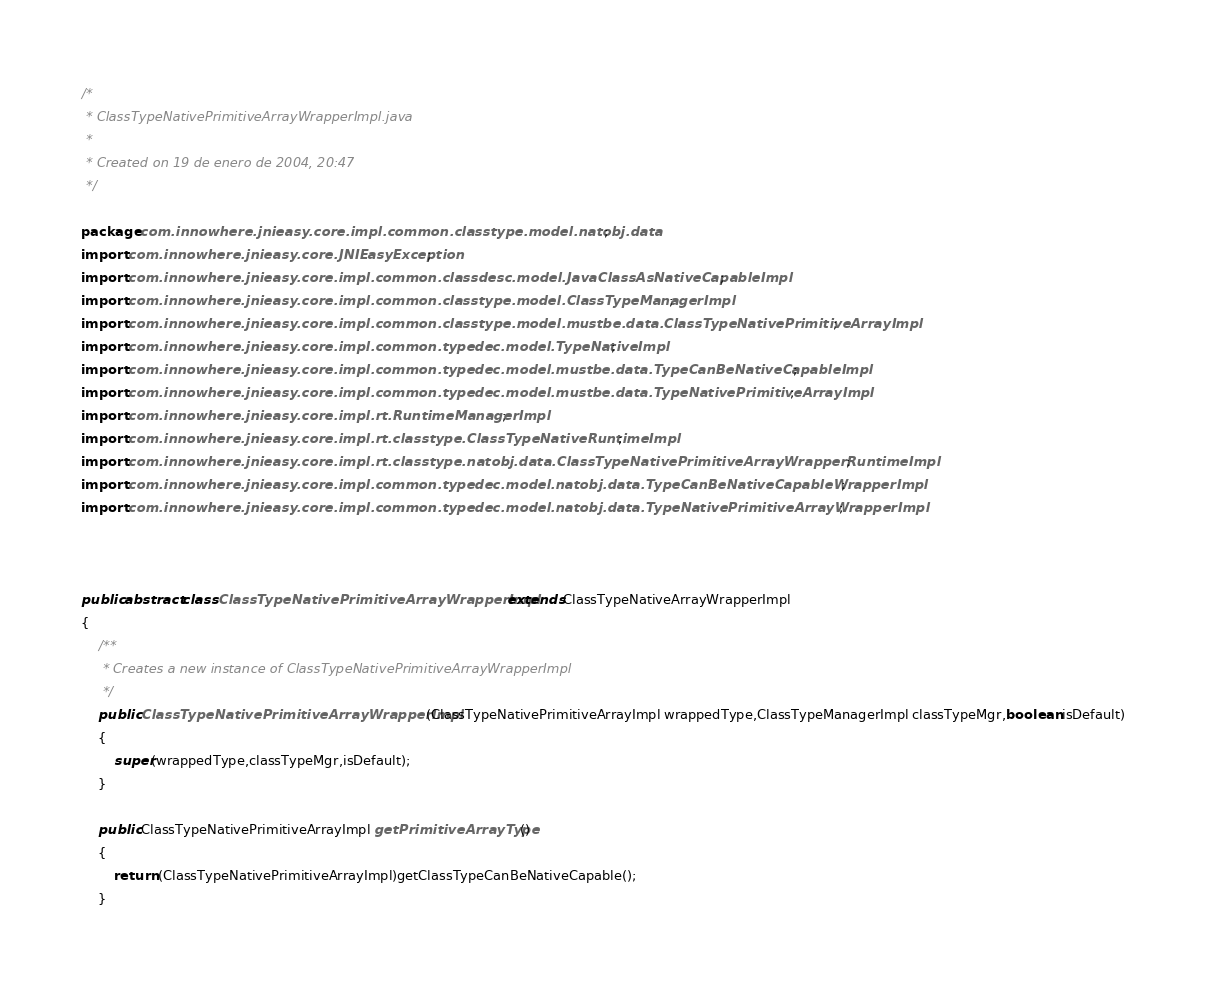Convert code to text. <code><loc_0><loc_0><loc_500><loc_500><_Java_>/*
 * ClassTypeNativePrimitiveArrayWrapperImpl.java
 *
 * Created on 19 de enero de 2004, 20:47
 */

package com.innowhere.jnieasy.core.impl.common.classtype.model.natobj.data;
import com.innowhere.jnieasy.core.JNIEasyException;
import com.innowhere.jnieasy.core.impl.common.classdesc.model.JavaClassAsNativeCapableImpl;
import com.innowhere.jnieasy.core.impl.common.classtype.model.ClassTypeManagerImpl;
import com.innowhere.jnieasy.core.impl.common.classtype.model.mustbe.data.ClassTypeNativePrimitiveArrayImpl;
import com.innowhere.jnieasy.core.impl.common.typedec.model.TypeNativeImpl;
import com.innowhere.jnieasy.core.impl.common.typedec.model.mustbe.data.TypeCanBeNativeCapableImpl;
import com.innowhere.jnieasy.core.impl.common.typedec.model.mustbe.data.TypeNativePrimitiveArrayImpl;
import com.innowhere.jnieasy.core.impl.rt.RuntimeManagerImpl;
import com.innowhere.jnieasy.core.impl.rt.classtype.ClassTypeNativeRuntimeImpl;
import com.innowhere.jnieasy.core.impl.rt.classtype.natobj.data.ClassTypeNativePrimitiveArrayWrapperRuntimeImpl;
import com.innowhere.jnieasy.core.impl.common.typedec.model.natobj.data.TypeCanBeNativeCapableWrapperImpl;
import com.innowhere.jnieasy.core.impl.common.typedec.model.natobj.data.TypeNativePrimitiveArrayWrapperImpl;



public abstract class ClassTypeNativePrimitiveArrayWrapperImpl extends ClassTypeNativeArrayWrapperImpl 
{
    /**
     * Creates a new instance of ClassTypeNativePrimitiveArrayWrapperImpl
     */
    public ClassTypeNativePrimitiveArrayWrapperImpl(ClassTypeNativePrimitiveArrayImpl wrappedType,ClassTypeManagerImpl classTypeMgr,boolean isDefault)
    {
        super(wrappedType,classTypeMgr,isDefault);
    }
    
    public ClassTypeNativePrimitiveArrayImpl getPrimitiveArrayType()    
    {
        return (ClassTypeNativePrimitiveArrayImpl)getClassTypeCanBeNativeCapable();
    }
</code> 